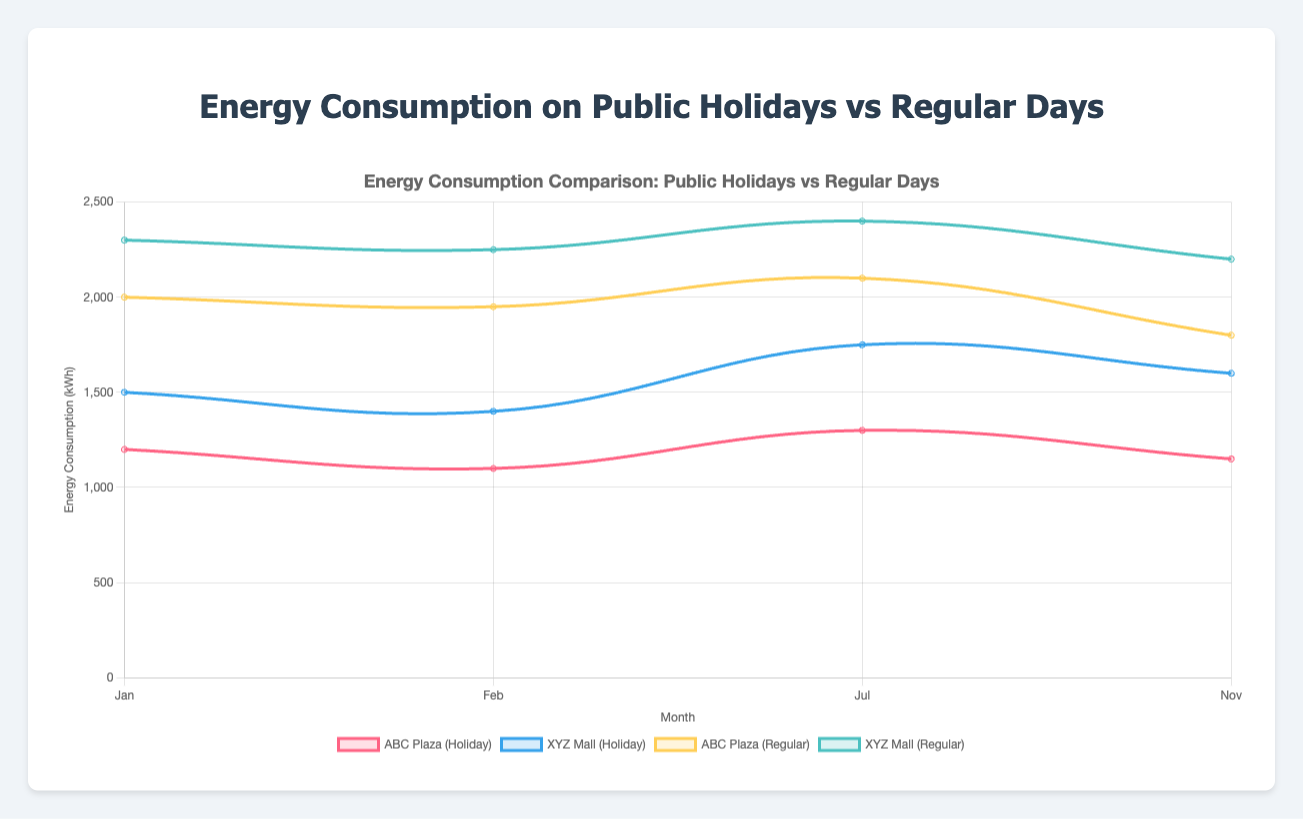How does the energy consumption of ABC Plaza during public holidays compare to regular days? To determine this, observe the curve for "ABC Plaza (Holiday)" and compare it against the curve for "ABC Plaza (Regular)". During public holidays, energy consumption at ABC Plaza ranges from 1100 kWh to 1300 kWh, whereas on regular days, it ranges from 1800 kWh to 2100 kWh. Thus, energy consumption is higher on regular days.
Answer: Regular days have higher energy consumption In which month did XYZ Mall have the highest energy consumption during a public holiday? Check the "XYZ Mall (Holiday)" curve and identify the highest point among the months displayed. The highest energy consumption during public holidays for XYZ Mall is in July, with 1750 kWh.
Answer: July What's the difference in average energy consumption between public holidays and regular days for ABC Plaza? Calculate the average for each: For public holidays, (1200 + 1100 + 1300 + 1150) / 4 = 1187.5 kWh. For regular days, (2000 + 1950 + 2100 + 1800) / 4 = 1962.5 kWh. The difference is 1962.5 - 1187.5 = 775 kWh.
Answer: 775 kWh Which building shows a larger overall decrease in energy consumption on public holidays compared to regular days? Calculate the average energy consumption on public holidays and regular days for both buildings. Compare the differences. For ABC Plaza, the difference is 1962.5 kWh - 1187.5 kWh = 775 kWh. For XYZ Mall, the difference is 2287.5 kWh - 1562.5 kWh = 725 kWh. ABC Plaza has a larger decrease.
Answer: ABC Plaza During which month is the energy consumption for XYZ Mall the lowest on a public holiday, and how does it compare to its regular days' consumption in the same month? Identify the lowest point on the "XYZ Mall (Holiday)" curve. In February, the consumption is 1400 kWh. On the regular day of February, the consumption is 2250 kWh.
Answer: February, lower on the holiday by 850 kWh 